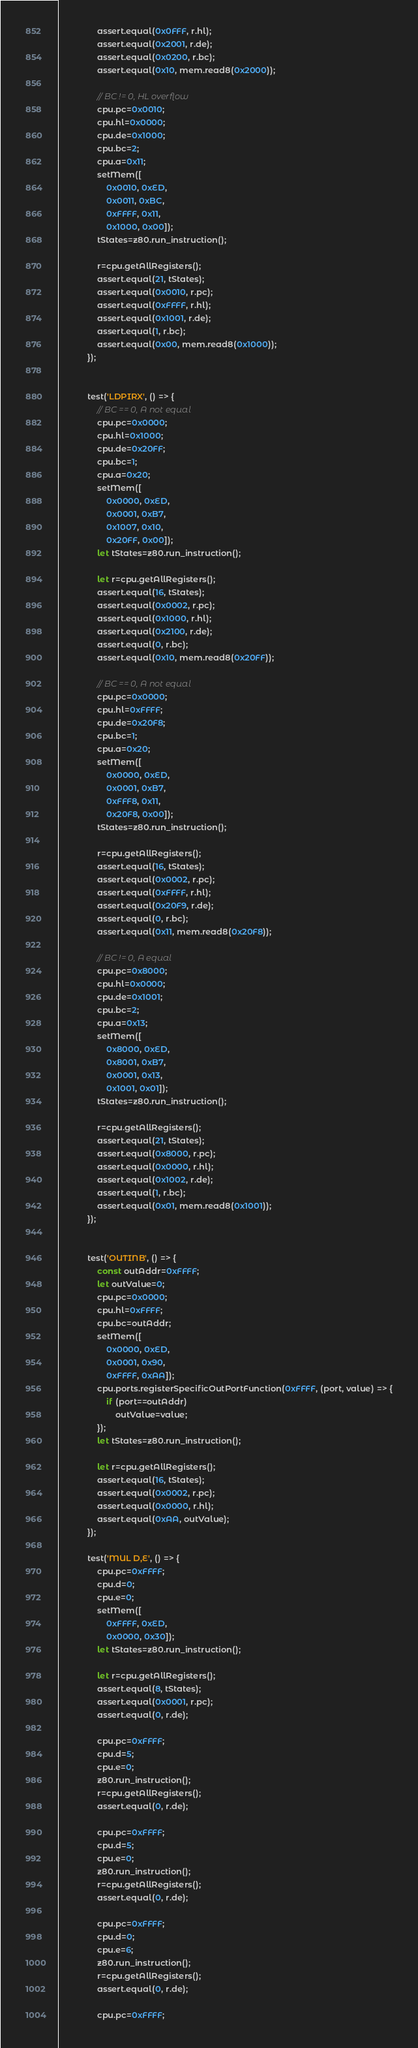Convert code to text. <code><loc_0><loc_0><loc_500><loc_500><_TypeScript_>				assert.equal(0x0FFF, r.hl);
				assert.equal(0x2001, r.de);
				assert.equal(0x0200, r.bc);
				assert.equal(0x10, mem.read8(0x2000));

				// BC != 0, HL overflow
				cpu.pc=0x0010;
				cpu.hl=0x0000;
				cpu.de=0x1000;
				cpu.bc=2;
				cpu.a=0x11;
				setMem([
					0x0010, 0xED,
					0x0011, 0xBC,
					0xFFFF, 0x11,
					0x1000, 0x00]);
				tStates=z80.run_instruction();

				r=cpu.getAllRegisters();
				assert.equal(21, tStates);
				assert.equal(0x0010, r.pc);
				assert.equal(0xFFFF, r.hl);
				assert.equal(0x1001, r.de);
				assert.equal(1, r.bc);
				assert.equal(0x00, mem.read8(0x1000));
			});


			test('LDPIRX', () => {
				// BC == 0, A not equal
				cpu.pc=0x0000;
				cpu.hl=0x1000;
				cpu.de=0x20FF;
				cpu.bc=1;
				cpu.a=0x20;
				setMem([
					0x0000, 0xED,
					0x0001, 0xB7,
					0x1007, 0x10,
					0x20FF, 0x00]);
				let tStates=z80.run_instruction();

				let r=cpu.getAllRegisters();
				assert.equal(16, tStates);
				assert.equal(0x0002, r.pc);
				assert.equal(0x1000, r.hl);
				assert.equal(0x2100, r.de);
				assert.equal(0, r.bc);
				assert.equal(0x10, mem.read8(0x20FF));

				// BC == 0, A not equal
				cpu.pc=0x0000;
				cpu.hl=0xFFFF;
				cpu.de=0x20F8;
				cpu.bc=1;
				cpu.a=0x20;
				setMem([
					0x0000, 0xED,
					0x0001, 0xB7,
					0xFFF8, 0x11,
					0x20F8, 0x00]);
				tStates=z80.run_instruction();

				r=cpu.getAllRegisters();
				assert.equal(16, tStates);
				assert.equal(0x0002, r.pc);
				assert.equal(0xFFFF, r.hl);
				assert.equal(0x20F9, r.de);
				assert.equal(0, r.bc);
				assert.equal(0x11, mem.read8(0x20F8));

				// BC != 0, A equal
				cpu.pc=0x8000;
				cpu.hl=0x0000;
				cpu.de=0x1001;
				cpu.bc=2;
				cpu.a=0x13;
				setMem([
					0x8000, 0xED,
					0x8001, 0xB7,
					0x0001, 0x13,
					0x1001, 0x01]);
				tStates=z80.run_instruction();

				r=cpu.getAllRegisters();
				assert.equal(21, tStates);
				assert.equal(0x8000, r.pc);
				assert.equal(0x0000, r.hl);
				assert.equal(0x1002, r.de);
				assert.equal(1, r.bc);
				assert.equal(0x01, mem.read8(0x1001));
			});


			test('OUTINB', () => {
				const outAddr=0xFFFF;
				let outValue=0;
				cpu.pc=0x0000;
				cpu.hl=0xFFFF;
				cpu.bc=outAddr;
				setMem([
					0x0000, 0xED,
					0x0001, 0x90,
					0xFFFF, 0xAA]);
				cpu.ports.registerSpecificOutPortFunction(0xFFFF, (port, value) => {
					if (port==outAddr)
						outValue=value;
				});
				let tStates=z80.run_instruction();

				let r=cpu.getAllRegisters();
				assert.equal(16, tStates);
				assert.equal(0x0002, r.pc);
				assert.equal(0x0000, r.hl);
				assert.equal(0xAA, outValue);
			});

			test('MUL D,E', () => {
				cpu.pc=0xFFFF;
				cpu.d=0;
				cpu.e=0;
				setMem([
					0xFFFF, 0xED,
					0x0000, 0x30]);
				let tStates=z80.run_instruction();

				let r=cpu.getAllRegisters();
				assert.equal(8, tStates);
				assert.equal(0x0001, r.pc);
				assert.equal(0, r.de);

				cpu.pc=0xFFFF;
				cpu.d=5;
				cpu.e=0;
				z80.run_instruction();
				r=cpu.getAllRegisters();
				assert.equal(0, r.de);

				cpu.pc=0xFFFF;
				cpu.d=5;
				cpu.e=0;
				z80.run_instruction();
				r=cpu.getAllRegisters();
				assert.equal(0, r.de);

				cpu.pc=0xFFFF;
				cpu.d=0;
				cpu.e=6;
				z80.run_instruction();
				r=cpu.getAllRegisters();
				assert.equal(0, r.de);

				cpu.pc=0xFFFF;</code> 